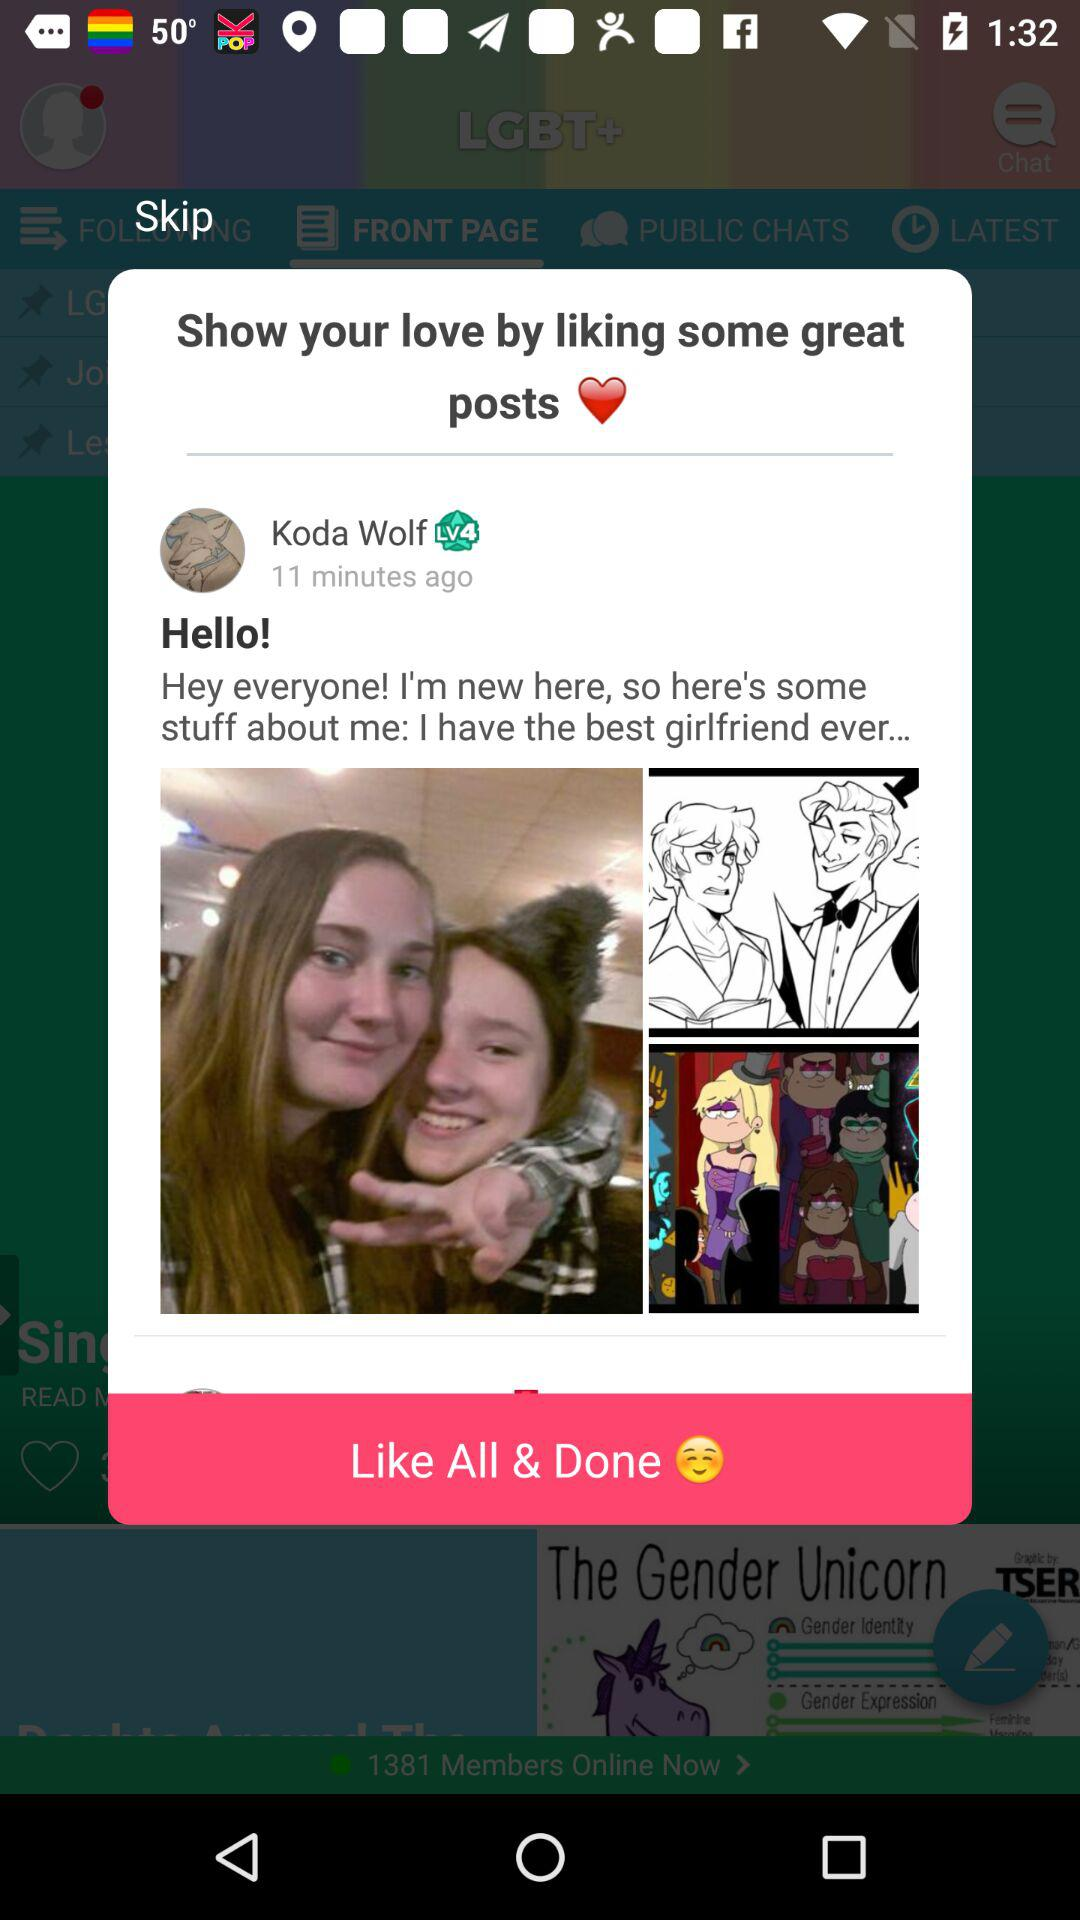How many minutes ago was the post posted? The post was posted 11 minutes ago. 